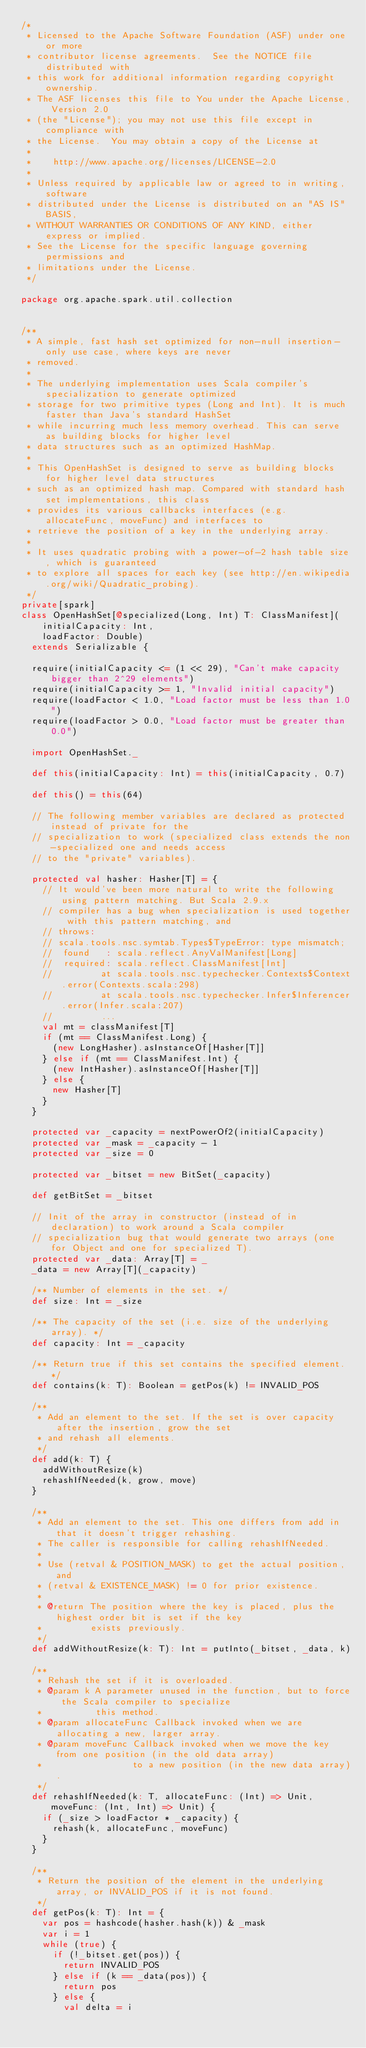<code> <loc_0><loc_0><loc_500><loc_500><_Scala_>/*
 * Licensed to the Apache Software Foundation (ASF) under one or more
 * contributor license agreements.  See the NOTICE file distributed with
 * this work for additional information regarding copyright ownership.
 * The ASF licenses this file to You under the Apache License, Version 2.0
 * (the "License"); you may not use this file except in compliance with
 * the License.  You may obtain a copy of the License at
 *
 *    http://www.apache.org/licenses/LICENSE-2.0
 *
 * Unless required by applicable law or agreed to in writing, software
 * distributed under the License is distributed on an "AS IS" BASIS,
 * WITHOUT WARRANTIES OR CONDITIONS OF ANY KIND, either express or implied.
 * See the License for the specific language governing permissions and
 * limitations under the License.
 */

package org.apache.spark.util.collection


/**
 * A simple, fast hash set optimized for non-null insertion-only use case, where keys are never
 * removed.
 *
 * The underlying implementation uses Scala compiler's specialization to generate optimized
 * storage for two primitive types (Long and Int). It is much faster than Java's standard HashSet
 * while incurring much less memory overhead. This can serve as building blocks for higher level
 * data structures such as an optimized HashMap.
 *
 * This OpenHashSet is designed to serve as building blocks for higher level data structures
 * such as an optimized hash map. Compared with standard hash set implementations, this class
 * provides its various callbacks interfaces (e.g. allocateFunc, moveFunc) and interfaces to
 * retrieve the position of a key in the underlying array.
 *
 * It uses quadratic probing with a power-of-2 hash table size, which is guaranteed
 * to explore all spaces for each key (see http://en.wikipedia.org/wiki/Quadratic_probing).
 */
private[spark]
class OpenHashSet[@specialized(Long, Int) T: ClassManifest](
    initialCapacity: Int,
    loadFactor: Double)
  extends Serializable {

  require(initialCapacity <= (1 << 29), "Can't make capacity bigger than 2^29 elements")
  require(initialCapacity >= 1, "Invalid initial capacity")
  require(loadFactor < 1.0, "Load factor must be less than 1.0")
  require(loadFactor > 0.0, "Load factor must be greater than 0.0")

  import OpenHashSet._

  def this(initialCapacity: Int) = this(initialCapacity, 0.7)

  def this() = this(64)

  // The following member variables are declared as protected instead of private for the
  // specialization to work (specialized class extends the non-specialized one and needs access
  // to the "private" variables).

  protected val hasher: Hasher[T] = {
    // It would've been more natural to write the following using pattern matching. But Scala 2.9.x
    // compiler has a bug when specialization is used together with this pattern matching, and
    // throws:
    // scala.tools.nsc.symtab.Types$TypeError: type mismatch;
    //  found   : scala.reflect.AnyValManifest[Long]
    //  required: scala.reflect.ClassManifest[Int]
    //         at scala.tools.nsc.typechecker.Contexts$Context.error(Contexts.scala:298)
    //         at scala.tools.nsc.typechecker.Infer$Inferencer.error(Infer.scala:207)
    //         ...
    val mt = classManifest[T]
    if (mt == ClassManifest.Long) {
      (new LongHasher).asInstanceOf[Hasher[T]]
    } else if (mt == ClassManifest.Int) {
      (new IntHasher).asInstanceOf[Hasher[T]]
    } else {
      new Hasher[T]
    }
  }

  protected var _capacity = nextPowerOf2(initialCapacity)
  protected var _mask = _capacity - 1
  protected var _size = 0

  protected var _bitset = new BitSet(_capacity)

  def getBitSet = _bitset

  // Init of the array in constructor (instead of in declaration) to work around a Scala compiler
  // specialization bug that would generate two arrays (one for Object and one for specialized T).
  protected var _data: Array[T] = _
  _data = new Array[T](_capacity)

  /** Number of elements in the set. */
  def size: Int = _size

  /** The capacity of the set (i.e. size of the underlying array). */
  def capacity: Int = _capacity

  /** Return true if this set contains the specified element. */
  def contains(k: T): Boolean = getPos(k) != INVALID_POS

  /**
   * Add an element to the set. If the set is over capacity after the insertion, grow the set
   * and rehash all elements.
   */
  def add(k: T) {
    addWithoutResize(k)
    rehashIfNeeded(k, grow, move)
  }

  /**
   * Add an element to the set. This one differs from add in that it doesn't trigger rehashing.
   * The caller is responsible for calling rehashIfNeeded.
   *
   * Use (retval & POSITION_MASK) to get the actual position, and
   * (retval & EXISTENCE_MASK) != 0 for prior existence.
   *
   * @return The position where the key is placed, plus the highest order bit is set if the key
   *         exists previously.
   */
  def addWithoutResize(k: T): Int = putInto(_bitset, _data, k)

  /**
   * Rehash the set if it is overloaded.
   * @param k A parameter unused in the function, but to force the Scala compiler to specialize
   *          this method.
   * @param allocateFunc Callback invoked when we are allocating a new, larger array.
   * @param moveFunc Callback invoked when we move the key from one position (in the old data array)
   *                 to a new position (in the new data array).
   */
  def rehashIfNeeded(k: T, allocateFunc: (Int) => Unit, moveFunc: (Int, Int) => Unit) {
    if (_size > loadFactor * _capacity) {
      rehash(k, allocateFunc, moveFunc)
    }
  }

  /**
   * Return the position of the element in the underlying array, or INVALID_POS if it is not found.
   */
  def getPos(k: T): Int = {
    var pos = hashcode(hasher.hash(k)) & _mask
    var i = 1
    while (true) {
      if (!_bitset.get(pos)) {
        return INVALID_POS
      } else if (k == _data(pos)) {
        return pos
      } else {
        val delta = i</code> 